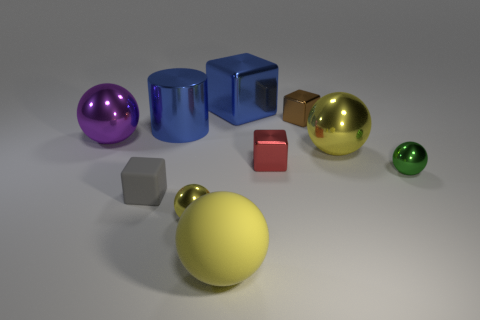Subtract all gray rubber blocks. How many blocks are left? 3 Subtract 1 cubes. How many cubes are left? 3 Subtract all red cylinders. How many yellow spheres are left? 3 Subtract all blue cubes. How many cubes are left? 3 Subtract all cyan cubes. Subtract all gray cylinders. How many cubes are left? 4 Add 5 tiny red things. How many tiny red things are left? 6 Add 2 big metal cubes. How many big metal cubes exist? 3 Subtract 0 red cylinders. How many objects are left? 10 Subtract all cubes. How many objects are left? 6 Subtract all big green shiny spheres. Subtract all tiny yellow metallic balls. How many objects are left? 9 